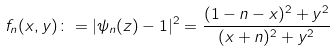<formula> <loc_0><loc_0><loc_500><loc_500>f _ { n } ( x , y ) \colon = | \psi _ { n } ( z ) - 1 | ^ { 2 } = \frac { ( 1 - n - x ) ^ { 2 } + y ^ { 2 } } { ( x + n ) ^ { 2 } + y ^ { 2 } }</formula> 